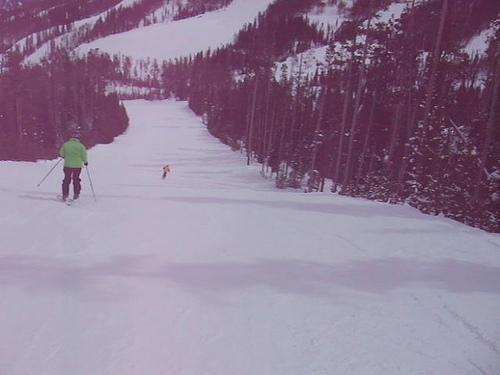How many people are shown?
Give a very brief answer. 2. 